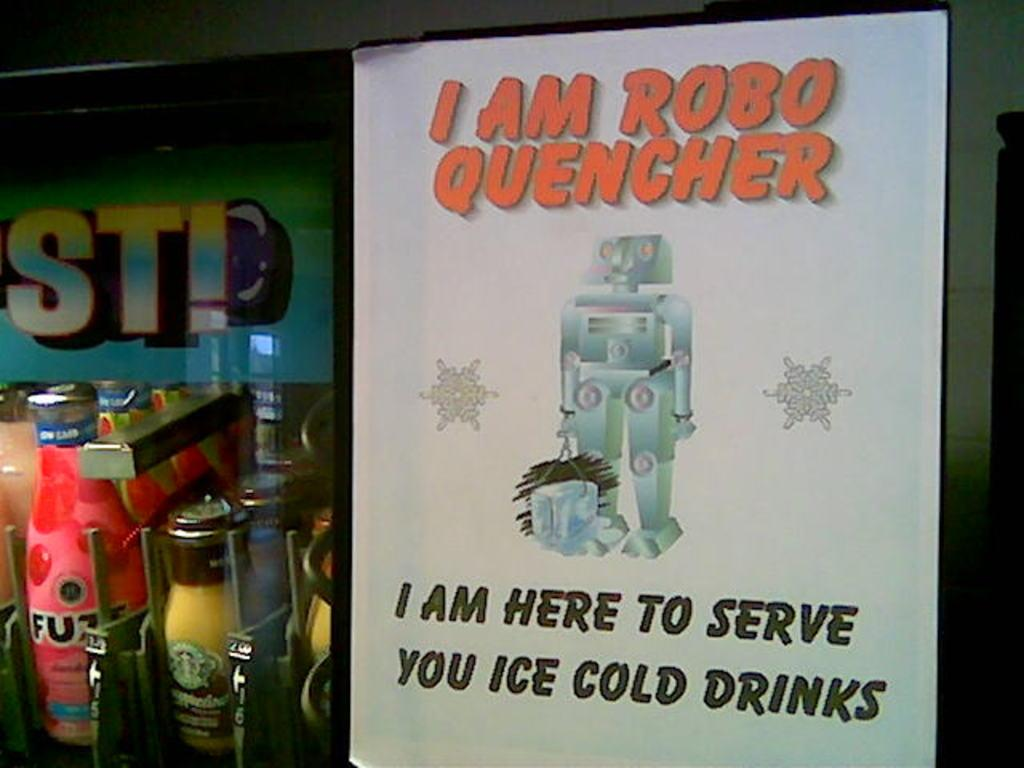<image>
Render a clear and concise summary of the photo. A cold drink robot server called, ROBO QUENCHER. 